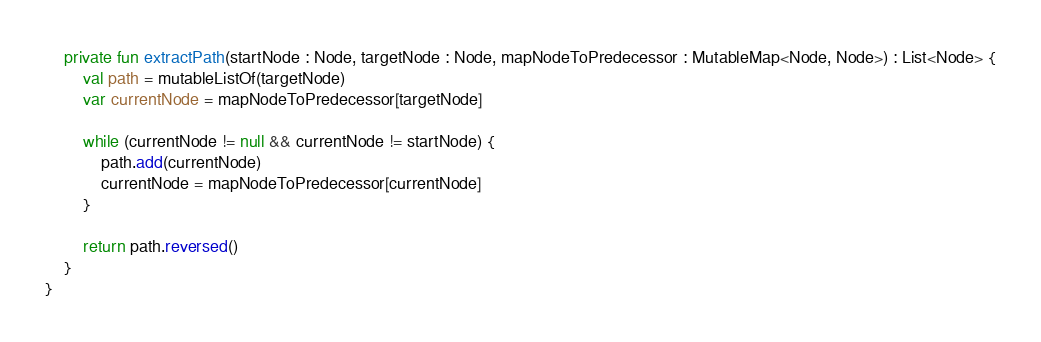<code> <loc_0><loc_0><loc_500><loc_500><_Kotlin_>
    private fun extractPath(startNode : Node, targetNode : Node, mapNodeToPredecessor : MutableMap<Node, Node>) : List<Node> {
        val path = mutableListOf(targetNode)
        var currentNode = mapNodeToPredecessor[targetNode]

        while (currentNode != null && currentNode != startNode) {
            path.add(currentNode)
            currentNode = mapNodeToPredecessor[currentNode]
        }

        return path.reversed()
    }
}</code> 